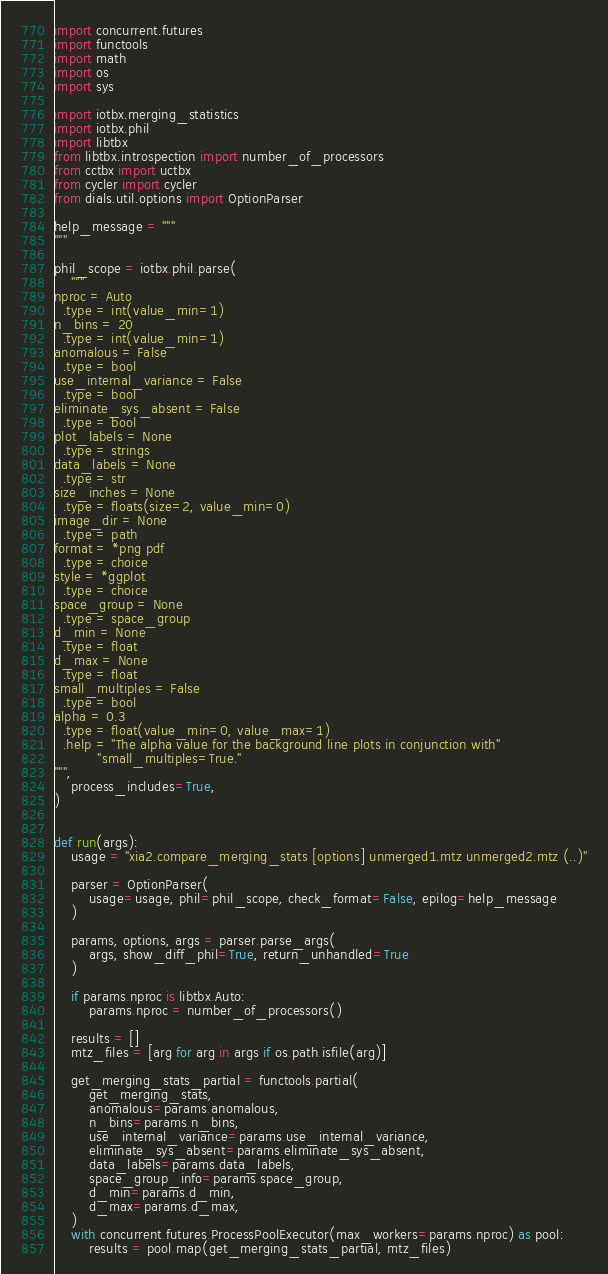<code> <loc_0><loc_0><loc_500><loc_500><_Python_>import concurrent.futures
import functools
import math
import os
import sys

import iotbx.merging_statistics
import iotbx.phil
import libtbx
from libtbx.introspection import number_of_processors
from cctbx import uctbx
from cycler import cycler
from dials.util.options import OptionParser

help_message = """
"""

phil_scope = iotbx.phil.parse(
    """
nproc = Auto
  .type = int(value_min=1)
n_bins = 20
  .type = int(value_min=1)
anomalous = False
  .type = bool
use_internal_variance = False
  .type = bool
eliminate_sys_absent = False
  .type = bool
plot_labels = None
  .type = strings
data_labels = None
  .type = str
size_inches = None
  .type = floats(size=2, value_min=0)
image_dir = None
  .type = path
format = *png pdf
  .type = choice
style = *ggplot
  .type = choice
space_group = None
  .type = space_group
d_min = None
  .type = float
d_max = None
  .type = float
small_multiples = False
  .type = bool
alpha = 0.3
  .type = float(value_min=0, value_max=1)
  .help = "The alpha value for the background line plots in conjunction with"
          "small_multiples=True."
""",
    process_includes=True,
)


def run(args):
    usage = "xia2.compare_merging_stats [options] unmerged1.mtz unmerged2.mtz (..)"

    parser = OptionParser(
        usage=usage, phil=phil_scope, check_format=False, epilog=help_message
    )

    params, options, args = parser.parse_args(
        args, show_diff_phil=True, return_unhandled=True
    )

    if params.nproc is libtbx.Auto:
        params.nproc = number_of_processors()

    results = []
    mtz_files = [arg for arg in args if os.path.isfile(arg)]

    get_merging_stats_partial = functools.partial(
        get_merging_stats,
        anomalous=params.anomalous,
        n_bins=params.n_bins,
        use_internal_variance=params.use_internal_variance,
        eliminate_sys_absent=params.eliminate_sys_absent,
        data_labels=params.data_labels,
        space_group_info=params.space_group,
        d_min=params.d_min,
        d_max=params.d_max,
    )
    with concurrent.futures.ProcessPoolExecutor(max_workers=params.nproc) as pool:
        results = pool.map(get_merging_stats_partial, mtz_files)
</code> 